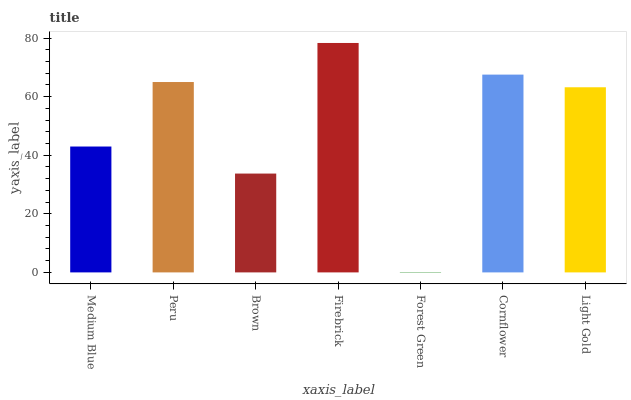Is Peru the minimum?
Answer yes or no. No. Is Peru the maximum?
Answer yes or no. No. Is Peru greater than Medium Blue?
Answer yes or no. Yes. Is Medium Blue less than Peru?
Answer yes or no. Yes. Is Medium Blue greater than Peru?
Answer yes or no. No. Is Peru less than Medium Blue?
Answer yes or no. No. Is Light Gold the high median?
Answer yes or no. Yes. Is Light Gold the low median?
Answer yes or no. Yes. Is Brown the high median?
Answer yes or no. No. Is Firebrick the low median?
Answer yes or no. No. 